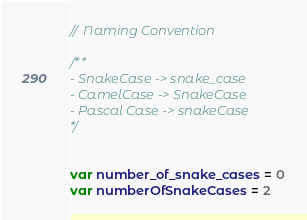<code> <loc_0><loc_0><loc_500><loc_500><_Swift_>// Naming Convention

/**
- SnakeCase -> snake_case
- CamelCase -> SnakeCase
- Pascal Case -> snakeCase
*/


var number_of_snake_cases = 0
var numberOfSnakeCases = 2
</code> 